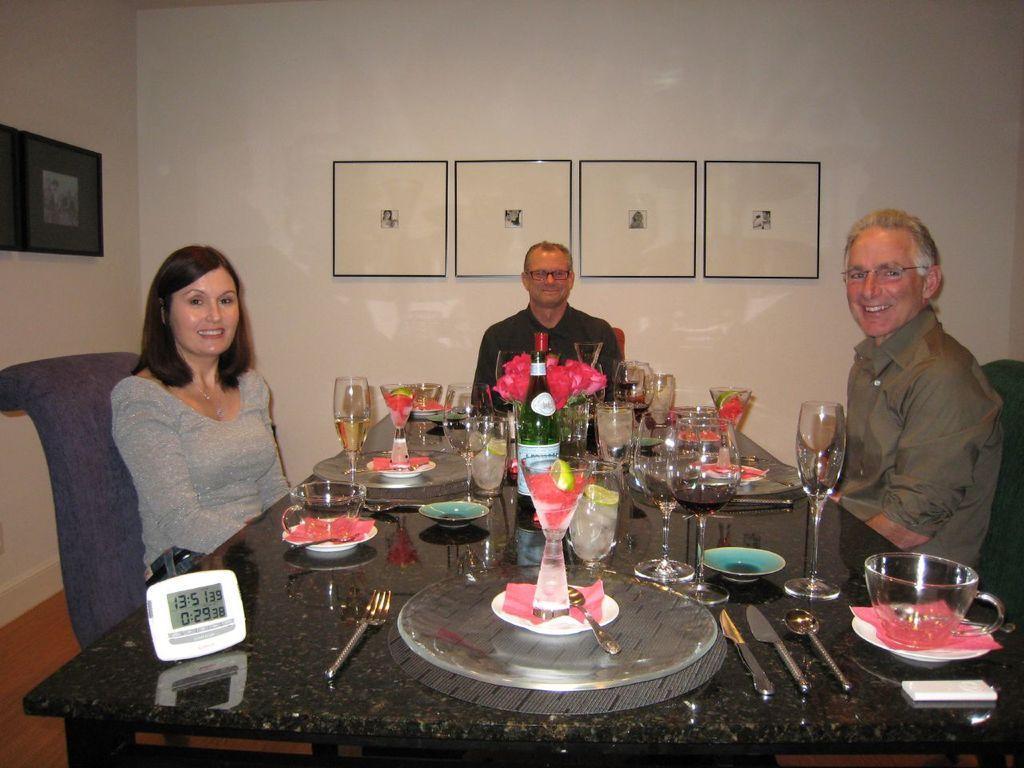How would you summarize this image in a sentence or two? to the left side there is a lady with grey t-shirt is sitting. To the right side there is a man with brown shirt is sitting and he is smiling. To the middle corner there is a man with black shirt is sitting and smiling. In between them there is a table with clock, cup with saucer, knife, spoon, glasses, bottle, plate and a fork on it. In the middle of the there are four frames. And to the left there are two frames. 